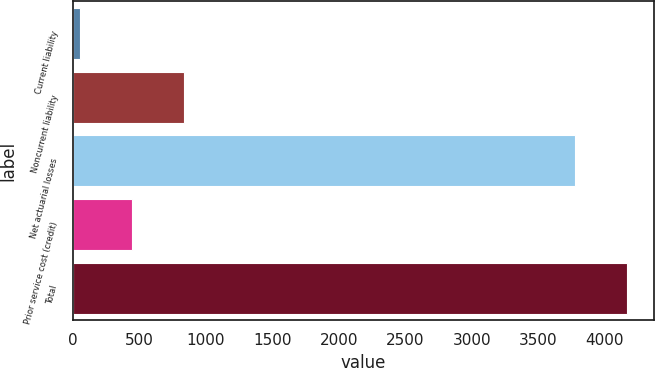Convert chart. <chart><loc_0><loc_0><loc_500><loc_500><bar_chart><fcel>Current liability<fcel>Noncurrent liability<fcel>Net actuarial losses<fcel>Prior service cost (credit)<fcel>Total<nl><fcel>55<fcel>835.6<fcel>3774<fcel>445.3<fcel>4164.3<nl></chart> 